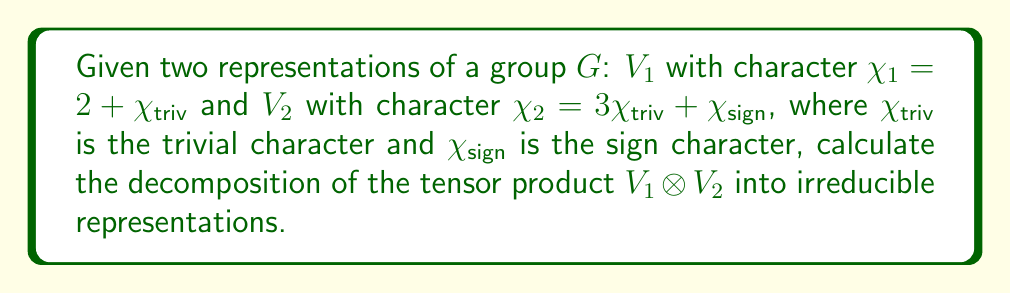Can you solve this math problem? To decompose the tensor product of two representations, we follow these steps:

1) First, recall that for characters $\chi_1$ and $\chi_2$, the character of their tensor product is given by the pointwise product: $\chi_{V_1 \otimes V_2} = \chi_1 \cdot \chi_2$.

2) Let's calculate this product:
   $\chi_{V_1 \otimes V_2} = (2 + \chi_{triv})(3\chi_{triv} + \chi_{sign})$
   
3) Expand the product:
   $\chi_{V_1 \otimes V_2} = 6\chi_{triv} + 2\chi_{sign} + 3\chi_{triv}^2 + \chi_{triv}\chi_{sign}$

4) Simplify, noting that $\chi_{triv}^2 = \chi_{triv}$ and $\chi_{triv}\chi_{sign} = \chi_{sign}$:
   $\chi_{V_1 \otimes V_2} = 9\chi_{triv} + 3\chi_{sign}$

5) This final expression gives us the decomposition of $V_1 \otimes V_2$ into irreducible representations:
   $V_1 \otimes V_2 \cong 9V_{triv} \oplus 3V_{sign}$

Where $V_{triv}$ is the trivial representation and $V_{sign}$ is the sign representation.
Answer: $9V_{triv} \oplus 3V_{sign}$ 